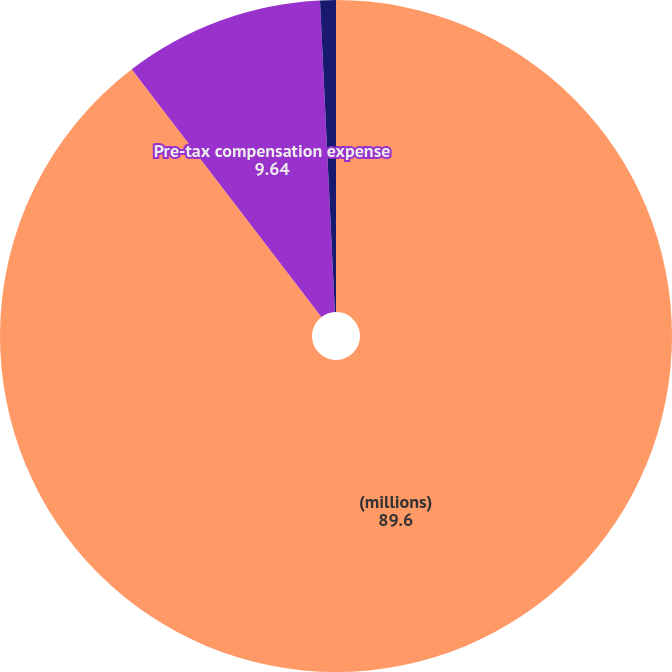<chart> <loc_0><loc_0><loc_500><loc_500><pie_chart><fcel>(millions)<fcel>Pre-tax compensation expense<fcel>Related income tax benefit<nl><fcel>89.6%<fcel>9.64%<fcel>0.76%<nl></chart> 